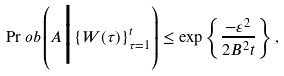<formula> <loc_0><loc_0><loc_500><loc_500>\Pr o b \left ( A \Big | \{ W ( \tau ) \} _ { \tau = 1 } ^ { t } \right ) \leq \exp \left \{ \frac { - \varepsilon ^ { 2 } } { 2 B ^ { 2 } t } \right \} ,</formula> 